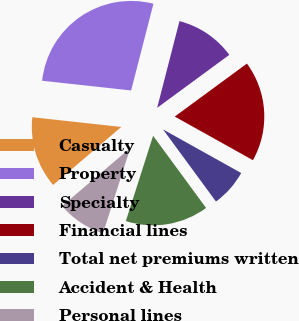Convert chart to OTSL. <chart><loc_0><loc_0><loc_500><loc_500><pie_chart><fcel>Casualty<fcel>Property<fcel>Specialty<fcel>Financial lines<fcel>Total net premiums written<fcel>Accident & Health<fcel>Personal lines<nl><fcel>12.95%<fcel>27.27%<fcel>10.91%<fcel>18.18%<fcel>6.82%<fcel>15.0%<fcel>8.86%<nl></chart> 